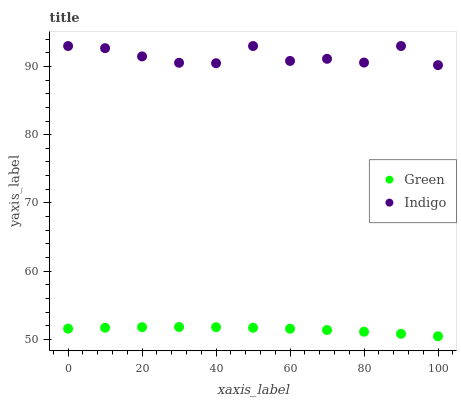Does Green have the minimum area under the curve?
Answer yes or no. Yes. Does Indigo have the maximum area under the curve?
Answer yes or no. Yes. Does Green have the maximum area under the curve?
Answer yes or no. No. Is Green the smoothest?
Answer yes or no. Yes. Is Indigo the roughest?
Answer yes or no. Yes. Is Green the roughest?
Answer yes or no. No. Does Green have the lowest value?
Answer yes or no. Yes. Does Indigo have the highest value?
Answer yes or no. Yes. Does Green have the highest value?
Answer yes or no. No. Is Green less than Indigo?
Answer yes or no. Yes. Is Indigo greater than Green?
Answer yes or no. Yes. Does Green intersect Indigo?
Answer yes or no. No. 